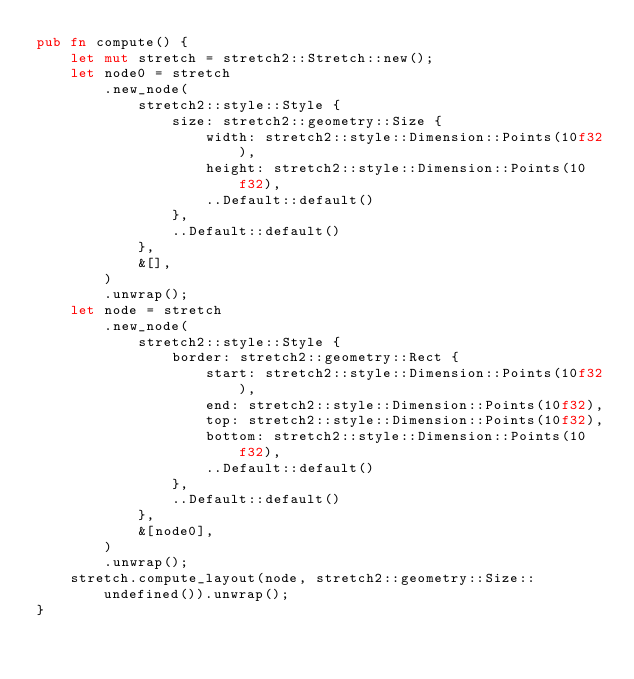<code> <loc_0><loc_0><loc_500><loc_500><_Rust_>pub fn compute() {
    let mut stretch = stretch2::Stretch::new();
    let node0 = stretch
        .new_node(
            stretch2::style::Style {
                size: stretch2::geometry::Size {
                    width: stretch2::style::Dimension::Points(10f32),
                    height: stretch2::style::Dimension::Points(10f32),
                    ..Default::default()
                },
                ..Default::default()
            },
            &[],
        )
        .unwrap();
    let node = stretch
        .new_node(
            stretch2::style::Style {
                border: stretch2::geometry::Rect {
                    start: stretch2::style::Dimension::Points(10f32),
                    end: stretch2::style::Dimension::Points(10f32),
                    top: stretch2::style::Dimension::Points(10f32),
                    bottom: stretch2::style::Dimension::Points(10f32),
                    ..Default::default()
                },
                ..Default::default()
            },
            &[node0],
        )
        .unwrap();
    stretch.compute_layout(node, stretch2::geometry::Size::undefined()).unwrap();
}
</code> 